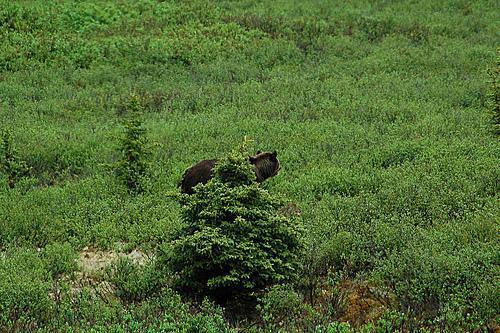How many bears are in the forest?
Give a very brief answer. 1. How many bears are here?
Give a very brief answer. 1. 